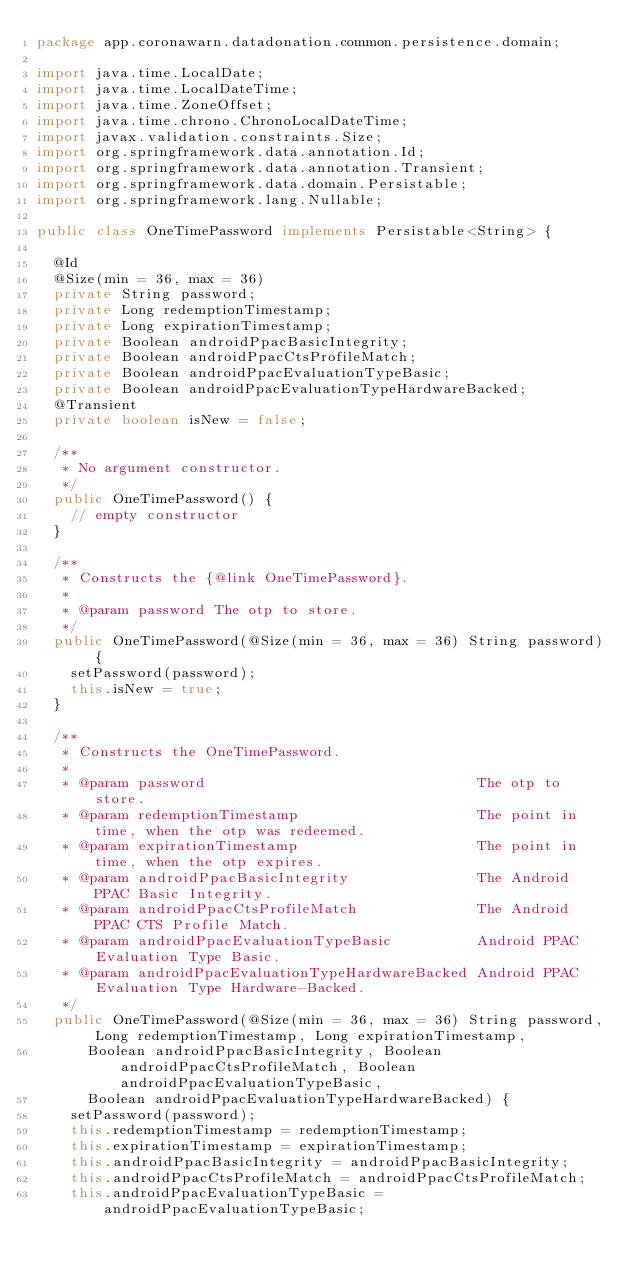Convert code to text. <code><loc_0><loc_0><loc_500><loc_500><_Java_>package app.coronawarn.datadonation.common.persistence.domain;

import java.time.LocalDate;
import java.time.LocalDateTime;
import java.time.ZoneOffset;
import java.time.chrono.ChronoLocalDateTime;
import javax.validation.constraints.Size;
import org.springframework.data.annotation.Id;
import org.springframework.data.annotation.Transient;
import org.springframework.data.domain.Persistable;
import org.springframework.lang.Nullable;

public class OneTimePassword implements Persistable<String> {

  @Id
  @Size(min = 36, max = 36)
  private String password;
  private Long redemptionTimestamp;
  private Long expirationTimestamp;
  private Boolean androidPpacBasicIntegrity;
  private Boolean androidPpacCtsProfileMatch;
  private Boolean androidPpacEvaluationTypeBasic;
  private Boolean androidPpacEvaluationTypeHardwareBacked;
  @Transient
  private boolean isNew = false;

  /**
   * No argument constructor.
   */
  public OneTimePassword() {
    // empty constructor
  }

  /**
   * Constructs the {@link OneTimePassword}.
   *
   * @param password The otp to store.
   */
  public OneTimePassword(@Size(min = 36, max = 36) String password) {
    setPassword(password);
    this.isNew = true;
  }

  /**
   * Constructs the OneTimePassword.
   *
   * @param password                                The otp to store.
   * @param redemptionTimestamp                     The point in time, when the otp was redeemed.
   * @param expirationTimestamp                     The point in time, when the otp expires.
   * @param androidPpacBasicIntegrity               The Android PPAC Basic Integrity.
   * @param androidPpacCtsProfileMatch              The Android PPAC CTS Profile Match.
   * @param androidPpacEvaluationTypeBasic          Android PPAC Evaluation Type Basic.
   * @param androidPpacEvaluationTypeHardwareBacked Android PPAC Evaluation Type Hardware-Backed.
   */
  public OneTimePassword(@Size(min = 36, max = 36) String password, Long redemptionTimestamp, Long expirationTimestamp,
      Boolean androidPpacBasicIntegrity, Boolean androidPpacCtsProfileMatch, Boolean androidPpacEvaluationTypeBasic,
      Boolean androidPpacEvaluationTypeHardwareBacked) {
    setPassword(password);
    this.redemptionTimestamp = redemptionTimestamp;
    this.expirationTimestamp = expirationTimestamp;
    this.androidPpacBasicIntegrity = androidPpacBasicIntegrity;
    this.androidPpacCtsProfileMatch = androidPpacCtsProfileMatch;
    this.androidPpacEvaluationTypeBasic = androidPpacEvaluationTypeBasic;</code> 